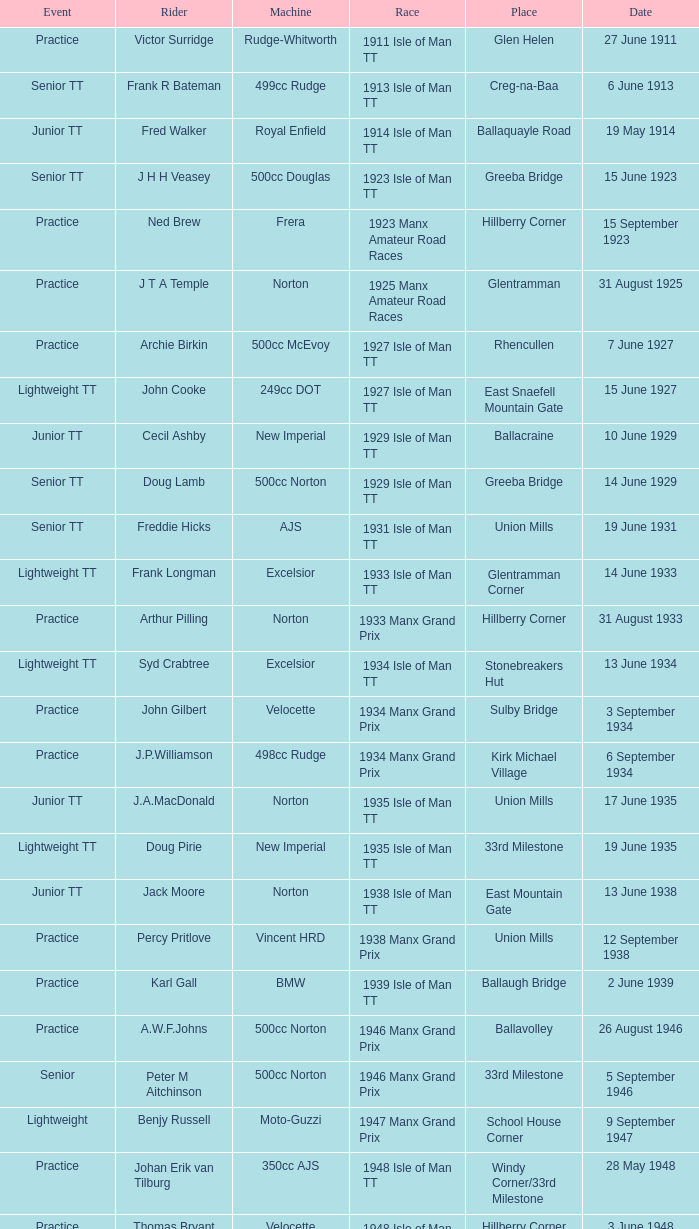Where was the 249cc Yamaha? Glentramman. 